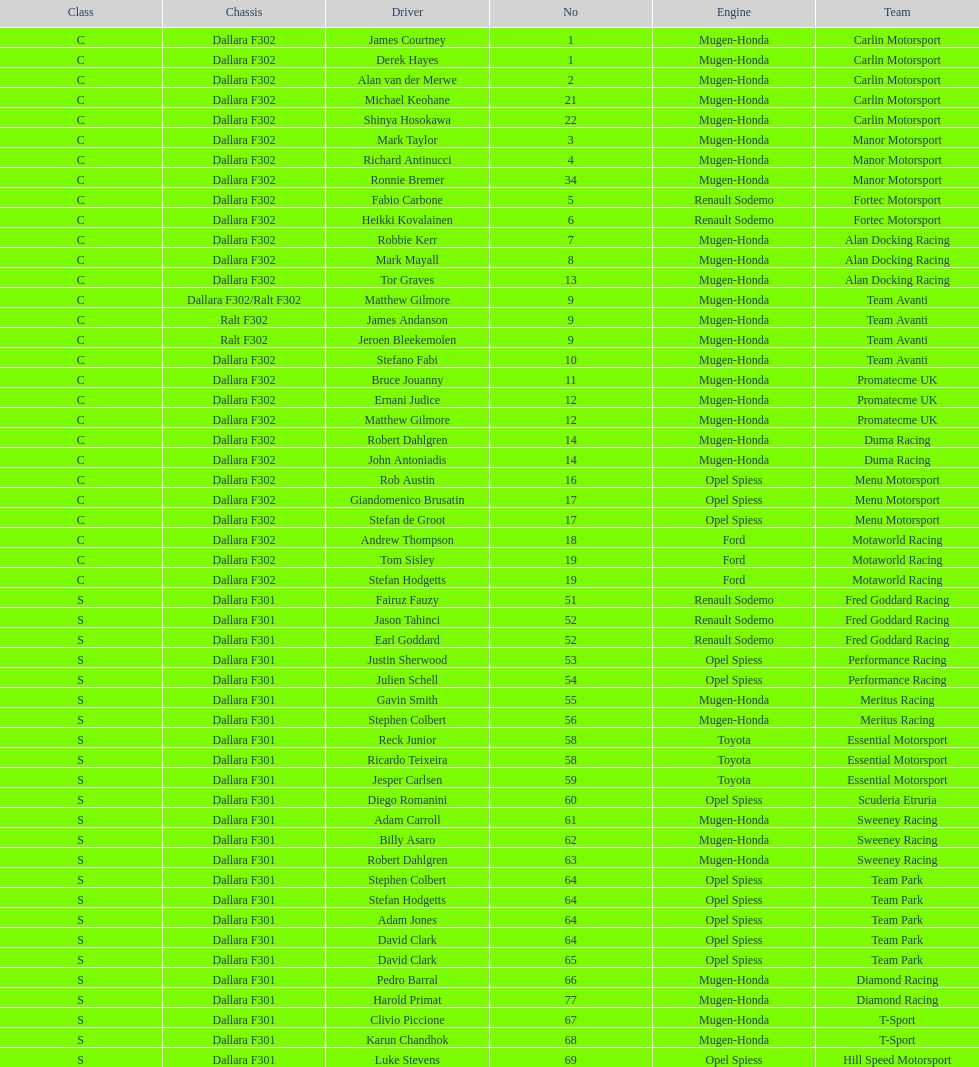What team is listed above diamond racing? Team Park. 